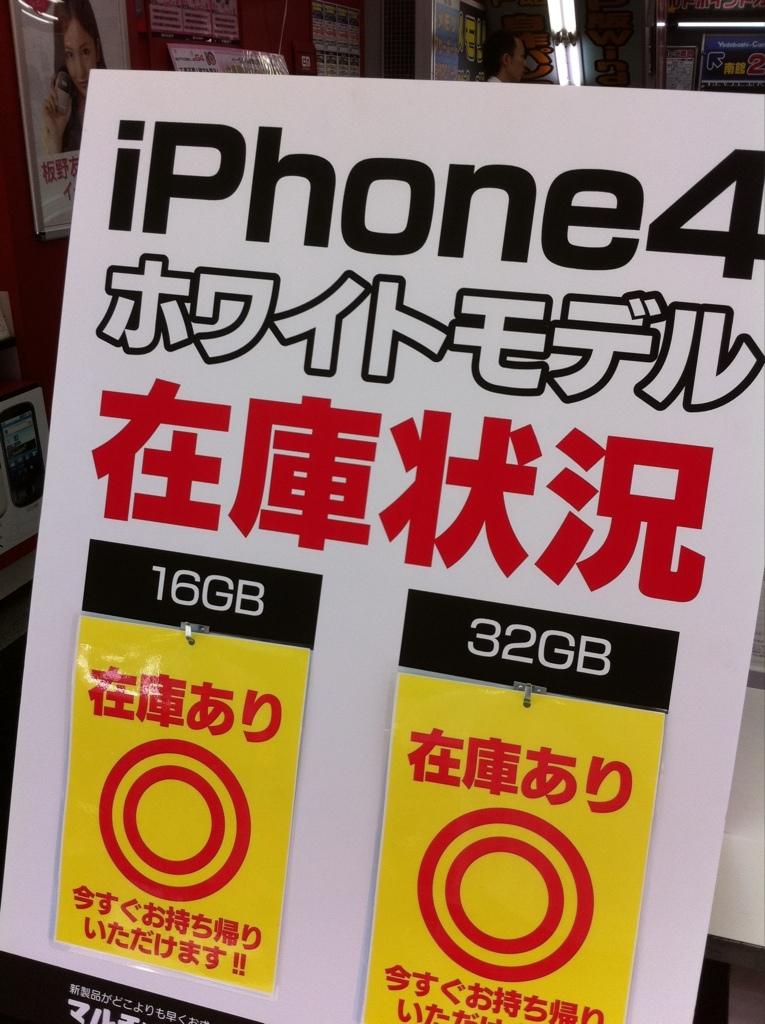Which iphone are they advertising?
Your response must be concise. Iphone 4. What two gb are they advertising?
Give a very brief answer. 16 and 32. 